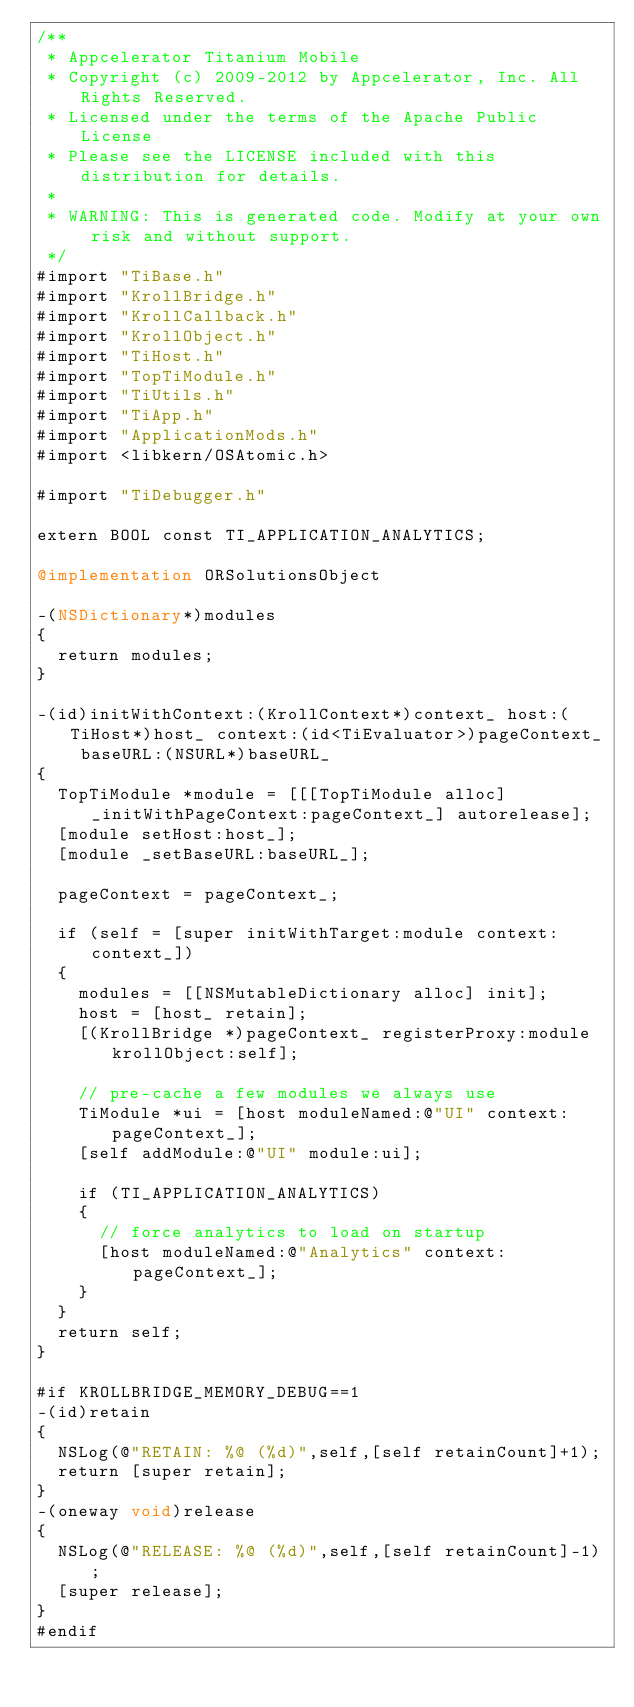Convert code to text. <code><loc_0><loc_0><loc_500><loc_500><_ObjectiveC_>/**
 * Appcelerator Titanium Mobile
 * Copyright (c) 2009-2012 by Appcelerator, Inc. All Rights Reserved.
 * Licensed under the terms of the Apache Public License
 * Please see the LICENSE included with this distribution for details.
 * 
 * WARNING: This is generated code. Modify at your own risk and without support.
 */
#import "TiBase.h"
#import "KrollBridge.h"
#import "KrollCallback.h"
#import "KrollObject.h"
#import "TiHost.h"
#import "TopTiModule.h"
#import "TiUtils.h"
#import "TiApp.h"
#import "ApplicationMods.h"
#import <libkern/OSAtomic.h>

#import "TiDebugger.h"

extern BOOL const TI_APPLICATION_ANALYTICS;

@implementation ORSolutionsObject

-(NSDictionary*)modules
{
	return modules;
}

-(id)initWithContext:(KrollContext*)context_ host:(TiHost*)host_ context:(id<TiEvaluator>)pageContext_ baseURL:(NSURL*)baseURL_
{
	TopTiModule *module = [[[TopTiModule alloc] _initWithPageContext:pageContext_] autorelease];
	[module setHost:host_];
	[module _setBaseURL:baseURL_];
	
	pageContext = pageContext_;
	
	if (self = [super initWithTarget:module context:context_])
	{
		modules = [[NSMutableDictionary alloc] init];
		host = [host_ retain];
		[(KrollBridge *)pageContext_ registerProxy:module krollObject:self];
		
		// pre-cache a few modules we always use
		TiModule *ui = [host moduleNamed:@"UI" context:pageContext_];
		[self addModule:@"UI" module:ui];
		
		if (TI_APPLICATION_ANALYTICS)
		{
			// force analytics to load on startup
			[host moduleNamed:@"Analytics" context:pageContext_];
		}
	}
	return self;
}

#if KROLLBRIDGE_MEMORY_DEBUG==1
-(id)retain
{
	NSLog(@"RETAIN: %@ (%d)",self,[self retainCount]+1);
	return [super retain];
}
-(oneway void)release 
{
	NSLog(@"RELEASE: %@ (%d)",self,[self retainCount]-1);
	[super release];
}
#endif
</code> 